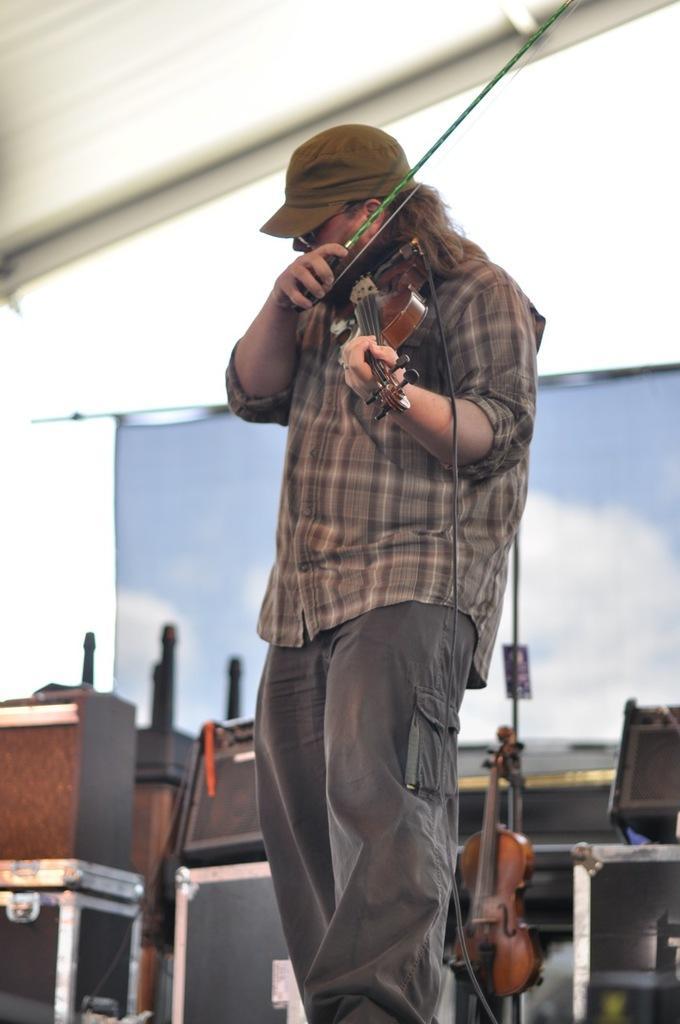Please provide a concise description of this image. In this picture there is a man holding and playing a violin. There are few other objects and violin at the background. 